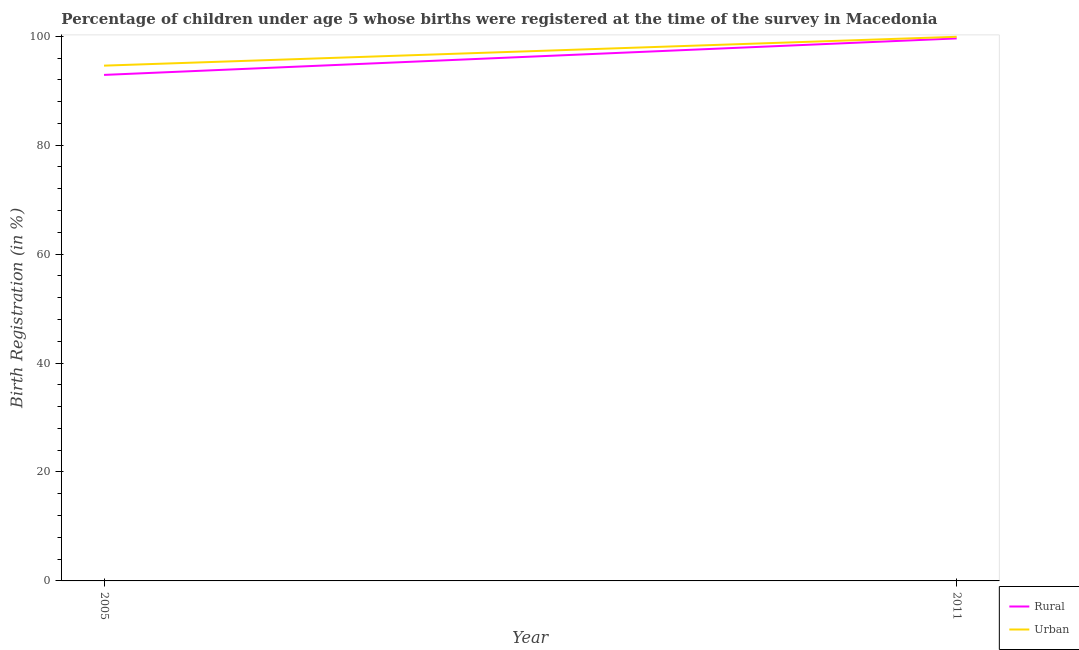How many different coloured lines are there?
Ensure brevity in your answer.  2. Does the line corresponding to rural birth registration intersect with the line corresponding to urban birth registration?
Make the answer very short. No. Is the number of lines equal to the number of legend labels?
Ensure brevity in your answer.  Yes. What is the rural birth registration in 2005?
Your answer should be compact. 92.9. Across all years, what is the maximum rural birth registration?
Offer a very short reply. 99.6. Across all years, what is the minimum rural birth registration?
Provide a succinct answer. 92.9. In which year was the urban birth registration minimum?
Offer a very short reply. 2005. What is the total urban birth registration in the graph?
Provide a short and direct response. 194.5. What is the difference between the rural birth registration in 2005 and that in 2011?
Provide a short and direct response. -6.7. What is the difference between the urban birth registration in 2011 and the rural birth registration in 2005?
Your response must be concise. 7. What is the average urban birth registration per year?
Give a very brief answer. 97.25. In the year 2005, what is the difference between the rural birth registration and urban birth registration?
Make the answer very short. -1.7. What is the ratio of the rural birth registration in 2005 to that in 2011?
Make the answer very short. 0.93. In how many years, is the rural birth registration greater than the average rural birth registration taken over all years?
Offer a terse response. 1. Does the rural birth registration monotonically increase over the years?
Ensure brevity in your answer.  Yes. Is the urban birth registration strictly greater than the rural birth registration over the years?
Make the answer very short. Yes. What is the difference between two consecutive major ticks on the Y-axis?
Provide a succinct answer. 20. Are the values on the major ticks of Y-axis written in scientific E-notation?
Provide a short and direct response. No. How many legend labels are there?
Give a very brief answer. 2. How are the legend labels stacked?
Offer a terse response. Vertical. What is the title of the graph?
Give a very brief answer. Percentage of children under age 5 whose births were registered at the time of the survey in Macedonia. Does "Tetanus" appear as one of the legend labels in the graph?
Provide a succinct answer. No. What is the label or title of the X-axis?
Keep it short and to the point. Year. What is the label or title of the Y-axis?
Provide a succinct answer. Birth Registration (in %). What is the Birth Registration (in %) in Rural in 2005?
Provide a short and direct response. 92.9. What is the Birth Registration (in %) in Urban in 2005?
Provide a short and direct response. 94.6. What is the Birth Registration (in %) of Rural in 2011?
Your response must be concise. 99.6. What is the Birth Registration (in %) in Urban in 2011?
Ensure brevity in your answer.  99.9. Across all years, what is the maximum Birth Registration (in %) of Rural?
Offer a very short reply. 99.6. Across all years, what is the maximum Birth Registration (in %) of Urban?
Your response must be concise. 99.9. Across all years, what is the minimum Birth Registration (in %) of Rural?
Your answer should be compact. 92.9. Across all years, what is the minimum Birth Registration (in %) of Urban?
Offer a very short reply. 94.6. What is the total Birth Registration (in %) in Rural in the graph?
Offer a terse response. 192.5. What is the total Birth Registration (in %) of Urban in the graph?
Provide a short and direct response. 194.5. What is the difference between the Birth Registration (in %) in Rural in 2005 and that in 2011?
Offer a very short reply. -6.7. What is the difference between the Birth Registration (in %) in Rural in 2005 and the Birth Registration (in %) in Urban in 2011?
Provide a short and direct response. -7. What is the average Birth Registration (in %) of Rural per year?
Offer a very short reply. 96.25. What is the average Birth Registration (in %) of Urban per year?
Offer a terse response. 97.25. What is the ratio of the Birth Registration (in %) in Rural in 2005 to that in 2011?
Make the answer very short. 0.93. What is the ratio of the Birth Registration (in %) of Urban in 2005 to that in 2011?
Provide a short and direct response. 0.95. What is the difference between the highest and the second highest Birth Registration (in %) in Rural?
Offer a terse response. 6.7. What is the difference between the highest and the lowest Birth Registration (in %) in Rural?
Your answer should be compact. 6.7. What is the difference between the highest and the lowest Birth Registration (in %) of Urban?
Your answer should be compact. 5.3. 